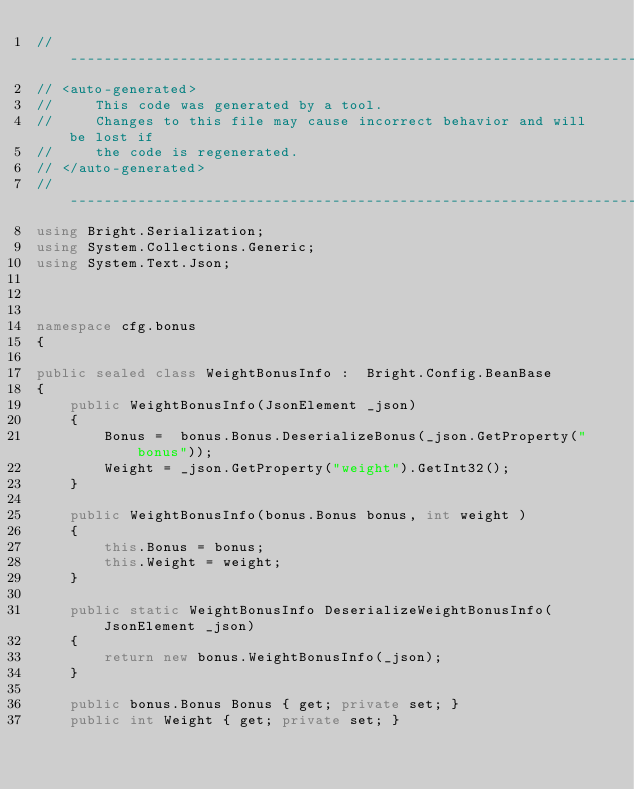<code> <loc_0><loc_0><loc_500><loc_500><_C#_>//------------------------------------------------------------------------------
// <auto-generated>
//     This code was generated by a tool.
//     Changes to this file may cause incorrect behavior and will be lost if
//     the code is regenerated.
// </auto-generated>
//------------------------------------------------------------------------------
using Bright.Serialization;
using System.Collections.Generic;
using System.Text.Json;



namespace cfg.bonus
{

public sealed class WeightBonusInfo :  Bright.Config.BeanBase 
{
    public WeightBonusInfo(JsonElement _json) 
    {
        Bonus =  bonus.Bonus.DeserializeBonus(_json.GetProperty("bonus"));
        Weight = _json.GetProperty("weight").GetInt32();
    }

    public WeightBonusInfo(bonus.Bonus bonus, int weight ) 
    {
        this.Bonus = bonus;
        this.Weight = weight;
    }

    public static WeightBonusInfo DeserializeWeightBonusInfo(JsonElement _json)
    {
        return new bonus.WeightBonusInfo(_json);
    }

    public bonus.Bonus Bonus { get; private set; }
    public int Weight { get; private set; }
</code> 